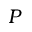<formula> <loc_0><loc_0><loc_500><loc_500>P</formula> 